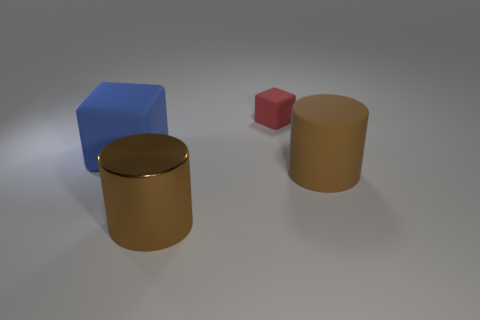Add 3 big metallic cubes. How many objects exist? 7 Subtract all brown cylinders. Subtract all small spheres. How many objects are left? 2 Add 4 matte blocks. How many matte blocks are left? 6 Add 3 brown things. How many brown things exist? 5 Subtract 0 yellow blocks. How many objects are left? 4 